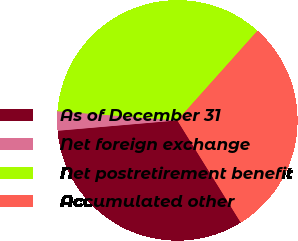Convert chart. <chart><loc_0><loc_0><loc_500><loc_500><pie_chart><fcel>As of December 31<fcel>Net foreign exchange<fcel>Net postretirement benefit<fcel>Accumulated other<nl><fcel>32.47%<fcel>2.59%<fcel>35.39%<fcel>29.55%<nl></chart> 